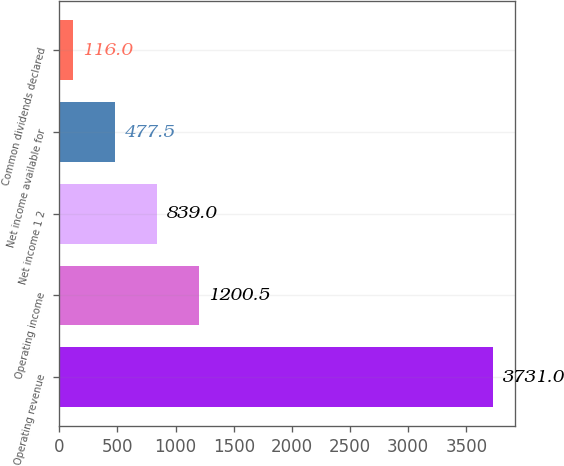<chart> <loc_0><loc_0><loc_500><loc_500><bar_chart><fcel>Operating revenue<fcel>Operating income<fcel>Net income 1 2<fcel>Net income available for<fcel>Common dividends declared<nl><fcel>3731<fcel>1200.5<fcel>839<fcel>477.5<fcel>116<nl></chart> 